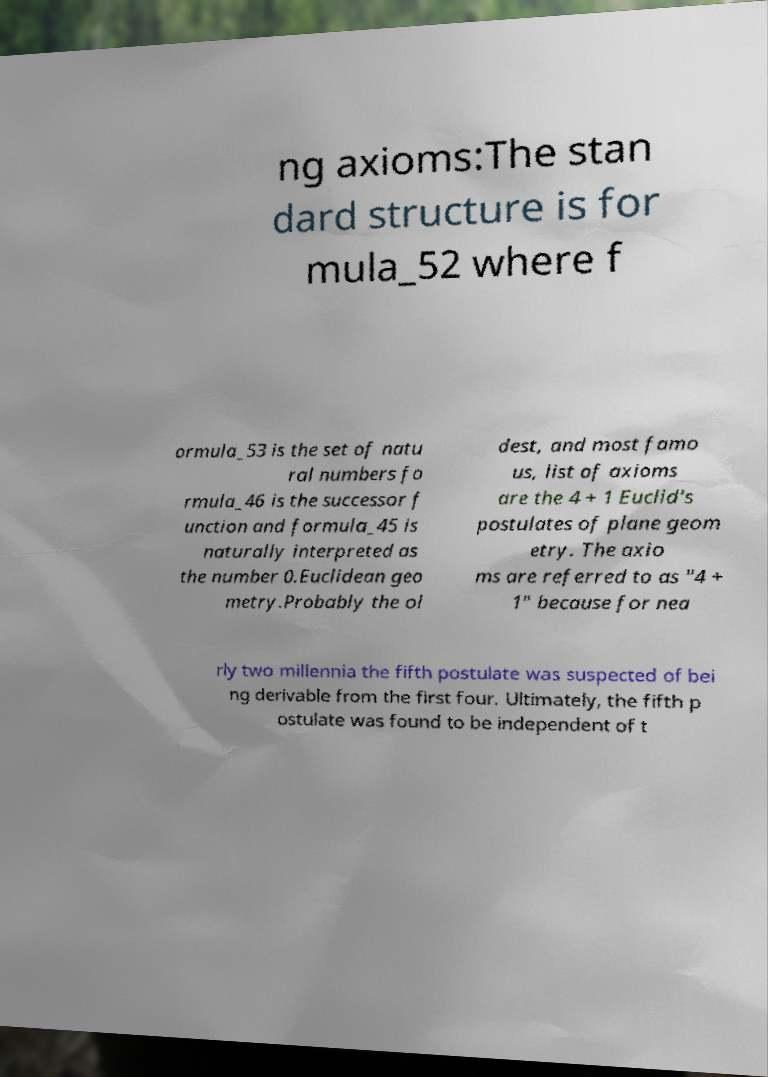Can you read and provide the text displayed in the image?This photo seems to have some interesting text. Can you extract and type it out for me? ng axioms:The stan dard structure is for mula_52 where f ormula_53 is the set of natu ral numbers fo rmula_46 is the successor f unction and formula_45 is naturally interpreted as the number 0.Euclidean geo metry.Probably the ol dest, and most famo us, list of axioms are the 4 + 1 Euclid's postulates of plane geom etry. The axio ms are referred to as "4 + 1" because for nea rly two millennia the fifth postulate was suspected of bei ng derivable from the first four. Ultimately, the fifth p ostulate was found to be independent of t 